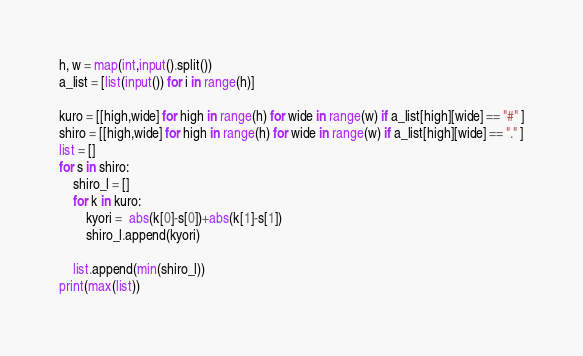<code> <loc_0><loc_0><loc_500><loc_500><_Python_>h, w = map(int,input().split())
a_list = [list(input()) for i in range(h)]

kuro = [[high,wide] for high in range(h) for wide in range(w) if a_list[high][wide] == "#" ]
shiro = [[high,wide] for high in range(h) for wide in range(w) if a_list[high][wide] == "." ]
list = []
for s in shiro:
    shiro_l = []
    for k in kuro:
        kyori =  abs(k[0]-s[0])+abs(k[1]-s[1])
        shiro_l.append(kyori)

    list.append(min(shiro_l))
print(max(list))
</code> 